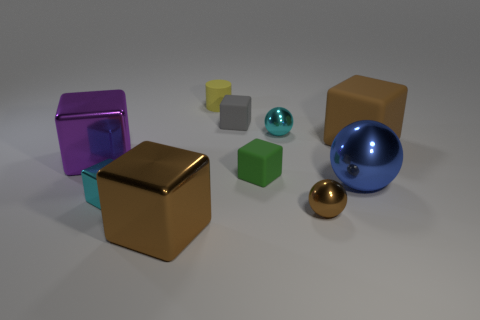There is a big shiny thing that is behind the big brown metallic block and on the right side of the tiny metal cube; what shape is it?
Provide a short and direct response. Sphere. Are there any rubber cubes of the same color as the big ball?
Your answer should be very brief. No. There is a tiny metal ball that is in front of the cyan shiny thing that is behind the big sphere; what color is it?
Make the answer very short. Brown. There is a cyan metal thing to the right of the metal thing in front of the tiny ball in front of the small cyan metallic cube; what size is it?
Offer a terse response. Small. Is the yellow cylinder made of the same material as the cyan thing that is behind the big sphere?
Keep it short and to the point. No. What size is the green object that is the same material as the gray block?
Make the answer very short. Small. Is there a yellow object of the same shape as the small green matte thing?
Keep it short and to the point. No. What number of objects are large shiny blocks that are to the left of the small yellow rubber cylinder or brown cubes?
Provide a short and direct response. 3. What size is the metal block that is the same color as the large rubber block?
Ensure brevity in your answer.  Large. Do the small object that is on the left side of the yellow cylinder and the cube behind the large brown rubber object have the same color?
Provide a succinct answer. No. 